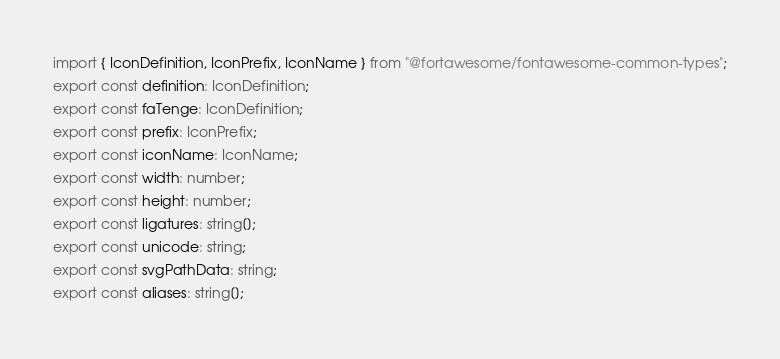Convert code to text. <code><loc_0><loc_0><loc_500><loc_500><_TypeScript_>import { IconDefinition, IconPrefix, IconName } from "@fortawesome/fontawesome-common-types";
export const definition: IconDefinition;
export const faTenge: IconDefinition;
export const prefix: IconPrefix;
export const iconName: IconName;
export const width: number;
export const height: number;
export const ligatures: string[];
export const unicode: string;
export const svgPathData: string;
export const aliases: string[];</code> 